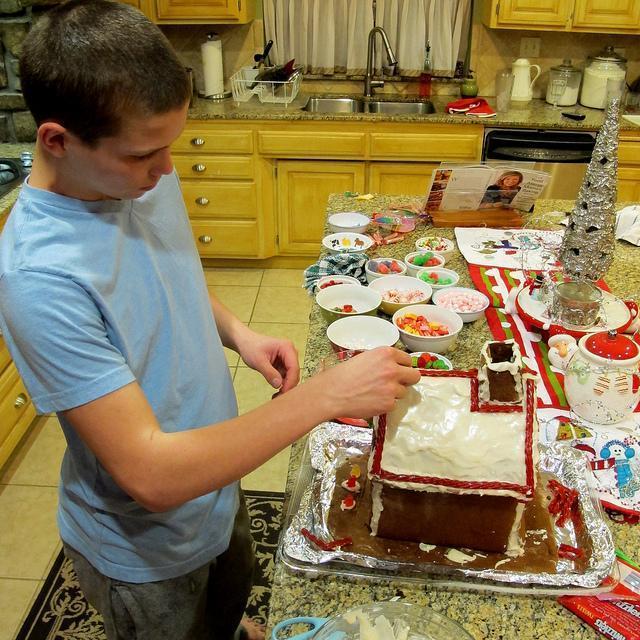How many bowls are there?
Give a very brief answer. 2. How many books are there?
Give a very brief answer. 1. 